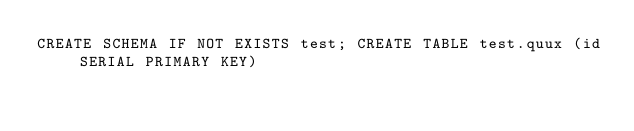Convert code to text. <code><loc_0><loc_0><loc_500><loc_500><_SQL_>CREATE SCHEMA IF NOT EXISTS test; CREATE TABLE test.quux (id SERIAL PRIMARY KEY)
</code> 